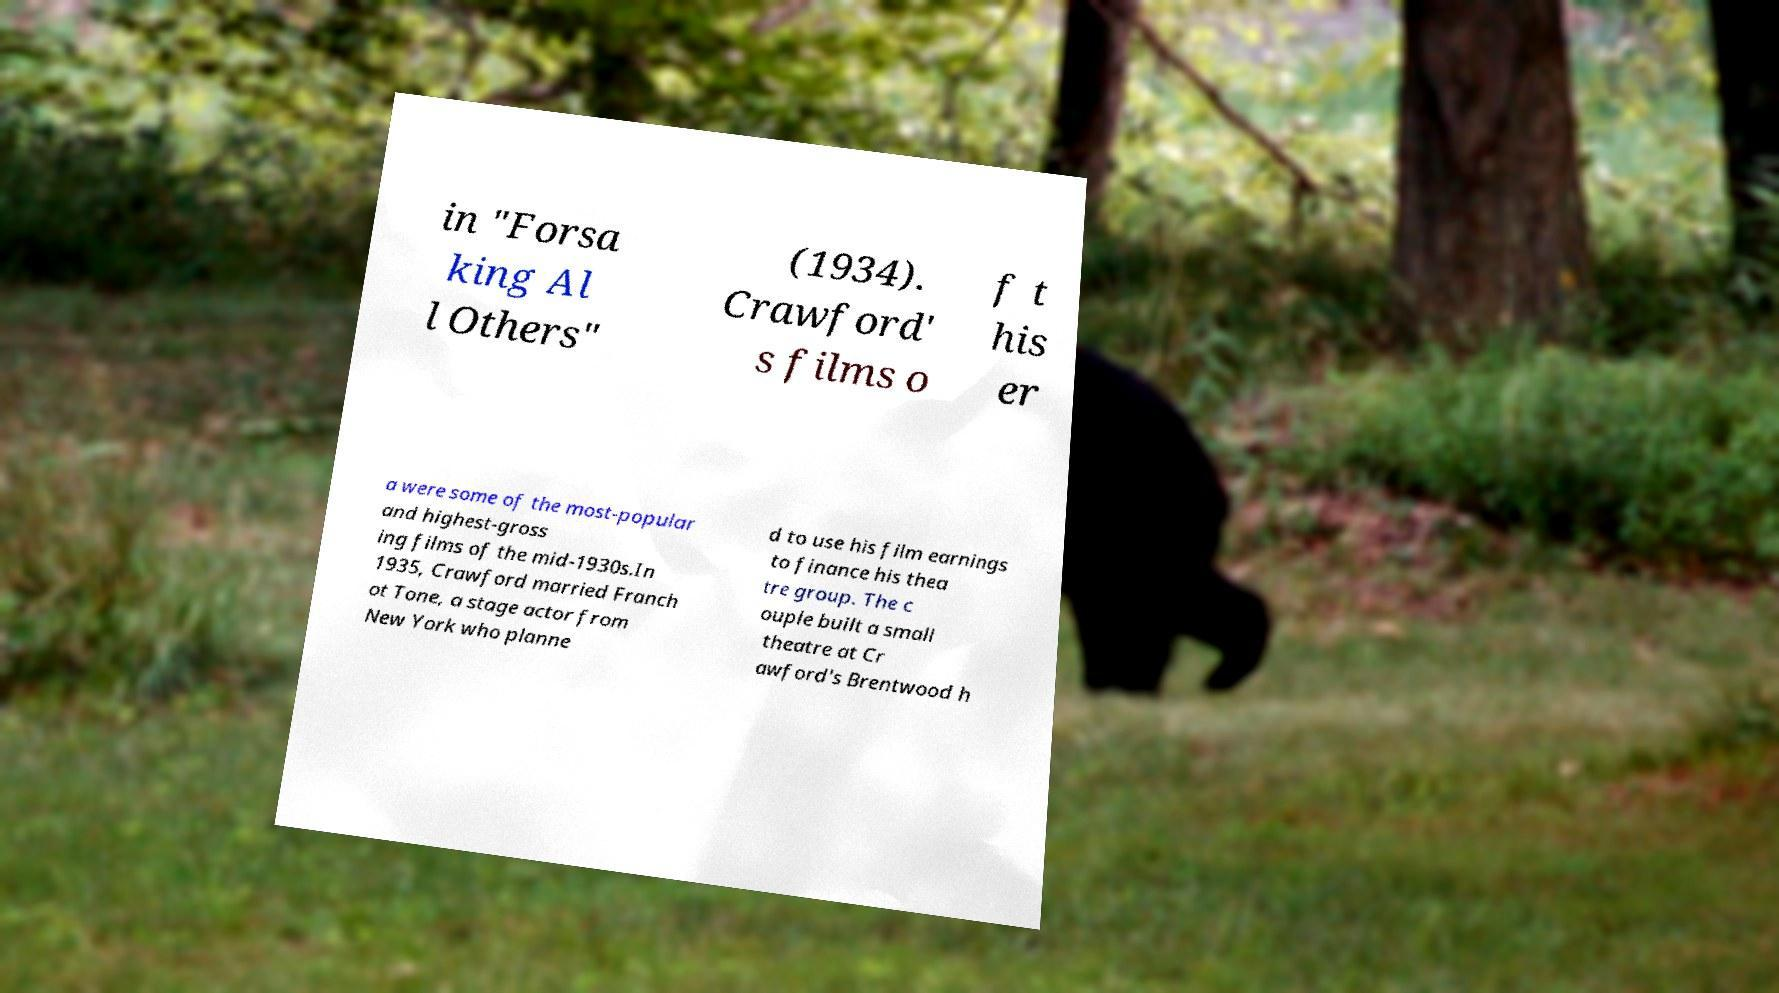Can you accurately transcribe the text from the provided image for me? in "Forsa king Al l Others" (1934). Crawford' s films o f t his er a were some of the most-popular and highest-gross ing films of the mid-1930s.In 1935, Crawford married Franch ot Tone, a stage actor from New York who planne d to use his film earnings to finance his thea tre group. The c ouple built a small theatre at Cr awford's Brentwood h 